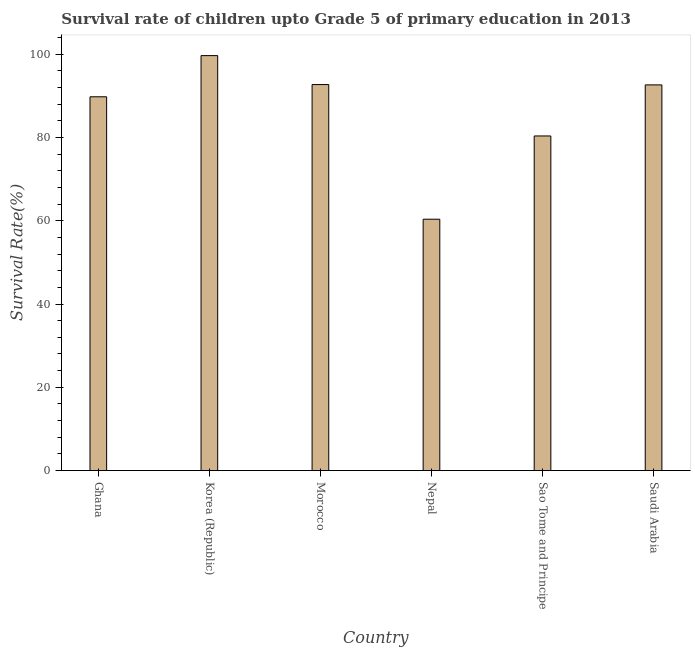What is the title of the graph?
Ensure brevity in your answer.  Survival rate of children upto Grade 5 of primary education in 2013 . What is the label or title of the Y-axis?
Your answer should be compact. Survival Rate(%). What is the survival rate in Saudi Arabia?
Offer a very short reply. 92.61. Across all countries, what is the maximum survival rate?
Give a very brief answer. 99.64. Across all countries, what is the minimum survival rate?
Ensure brevity in your answer.  60.36. In which country was the survival rate minimum?
Give a very brief answer. Nepal. What is the sum of the survival rate?
Make the answer very short. 515.42. What is the difference between the survival rate in Nepal and Sao Tome and Principe?
Make the answer very short. -19.99. What is the average survival rate per country?
Provide a short and direct response. 85.9. What is the median survival rate?
Offer a very short reply. 91.18. Is the survival rate in Ghana less than that in Korea (Republic)?
Your answer should be compact. Yes. Is the difference between the survival rate in Korea (Republic) and Saudi Arabia greater than the difference between any two countries?
Give a very brief answer. No. What is the difference between the highest and the second highest survival rate?
Give a very brief answer. 6.95. What is the difference between the highest and the lowest survival rate?
Provide a succinct answer. 39.28. In how many countries, is the survival rate greater than the average survival rate taken over all countries?
Provide a succinct answer. 4. How many bars are there?
Give a very brief answer. 6. Are the values on the major ticks of Y-axis written in scientific E-notation?
Your response must be concise. No. What is the Survival Rate(%) of Ghana?
Make the answer very short. 89.76. What is the Survival Rate(%) of Korea (Republic)?
Provide a succinct answer. 99.64. What is the Survival Rate(%) of Morocco?
Your answer should be very brief. 92.69. What is the Survival Rate(%) in Nepal?
Your answer should be very brief. 60.36. What is the Survival Rate(%) in Sao Tome and Principe?
Keep it short and to the point. 80.35. What is the Survival Rate(%) in Saudi Arabia?
Your response must be concise. 92.61. What is the difference between the Survival Rate(%) in Ghana and Korea (Republic)?
Provide a short and direct response. -9.89. What is the difference between the Survival Rate(%) in Ghana and Morocco?
Offer a terse response. -2.94. What is the difference between the Survival Rate(%) in Ghana and Nepal?
Provide a succinct answer. 29.4. What is the difference between the Survival Rate(%) in Ghana and Sao Tome and Principe?
Ensure brevity in your answer.  9.41. What is the difference between the Survival Rate(%) in Ghana and Saudi Arabia?
Your answer should be compact. -2.86. What is the difference between the Survival Rate(%) in Korea (Republic) and Morocco?
Give a very brief answer. 6.95. What is the difference between the Survival Rate(%) in Korea (Republic) and Nepal?
Ensure brevity in your answer.  39.28. What is the difference between the Survival Rate(%) in Korea (Republic) and Sao Tome and Principe?
Offer a terse response. 19.29. What is the difference between the Survival Rate(%) in Korea (Republic) and Saudi Arabia?
Make the answer very short. 7.03. What is the difference between the Survival Rate(%) in Morocco and Nepal?
Your response must be concise. 32.33. What is the difference between the Survival Rate(%) in Morocco and Sao Tome and Principe?
Provide a succinct answer. 12.34. What is the difference between the Survival Rate(%) in Morocco and Saudi Arabia?
Your answer should be very brief. 0.08. What is the difference between the Survival Rate(%) in Nepal and Sao Tome and Principe?
Ensure brevity in your answer.  -19.99. What is the difference between the Survival Rate(%) in Nepal and Saudi Arabia?
Give a very brief answer. -32.25. What is the difference between the Survival Rate(%) in Sao Tome and Principe and Saudi Arabia?
Make the answer very short. -12.26. What is the ratio of the Survival Rate(%) in Ghana to that in Korea (Republic)?
Give a very brief answer. 0.9. What is the ratio of the Survival Rate(%) in Ghana to that in Nepal?
Provide a succinct answer. 1.49. What is the ratio of the Survival Rate(%) in Ghana to that in Sao Tome and Principe?
Make the answer very short. 1.12. What is the ratio of the Survival Rate(%) in Ghana to that in Saudi Arabia?
Offer a terse response. 0.97. What is the ratio of the Survival Rate(%) in Korea (Republic) to that in Morocco?
Your answer should be very brief. 1.07. What is the ratio of the Survival Rate(%) in Korea (Republic) to that in Nepal?
Give a very brief answer. 1.65. What is the ratio of the Survival Rate(%) in Korea (Republic) to that in Sao Tome and Principe?
Your answer should be very brief. 1.24. What is the ratio of the Survival Rate(%) in Korea (Republic) to that in Saudi Arabia?
Give a very brief answer. 1.08. What is the ratio of the Survival Rate(%) in Morocco to that in Nepal?
Your answer should be very brief. 1.54. What is the ratio of the Survival Rate(%) in Morocco to that in Sao Tome and Principe?
Your response must be concise. 1.15. What is the ratio of the Survival Rate(%) in Morocco to that in Saudi Arabia?
Provide a short and direct response. 1. What is the ratio of the Survival Rate(%) in Nepal to that in Sao Tome and Principe?
Ensure brevity in your answer.  0.75. What is the ratio of the Survival Rate(%) in Nepal to that in Saudi Arabia?
Your answer should be compact. 0.65. What is the ratio of the Survival Rate(%) in Sao Tome and Principe to that in Saudi Arabia?
Give a very brief answer. 0.87. 